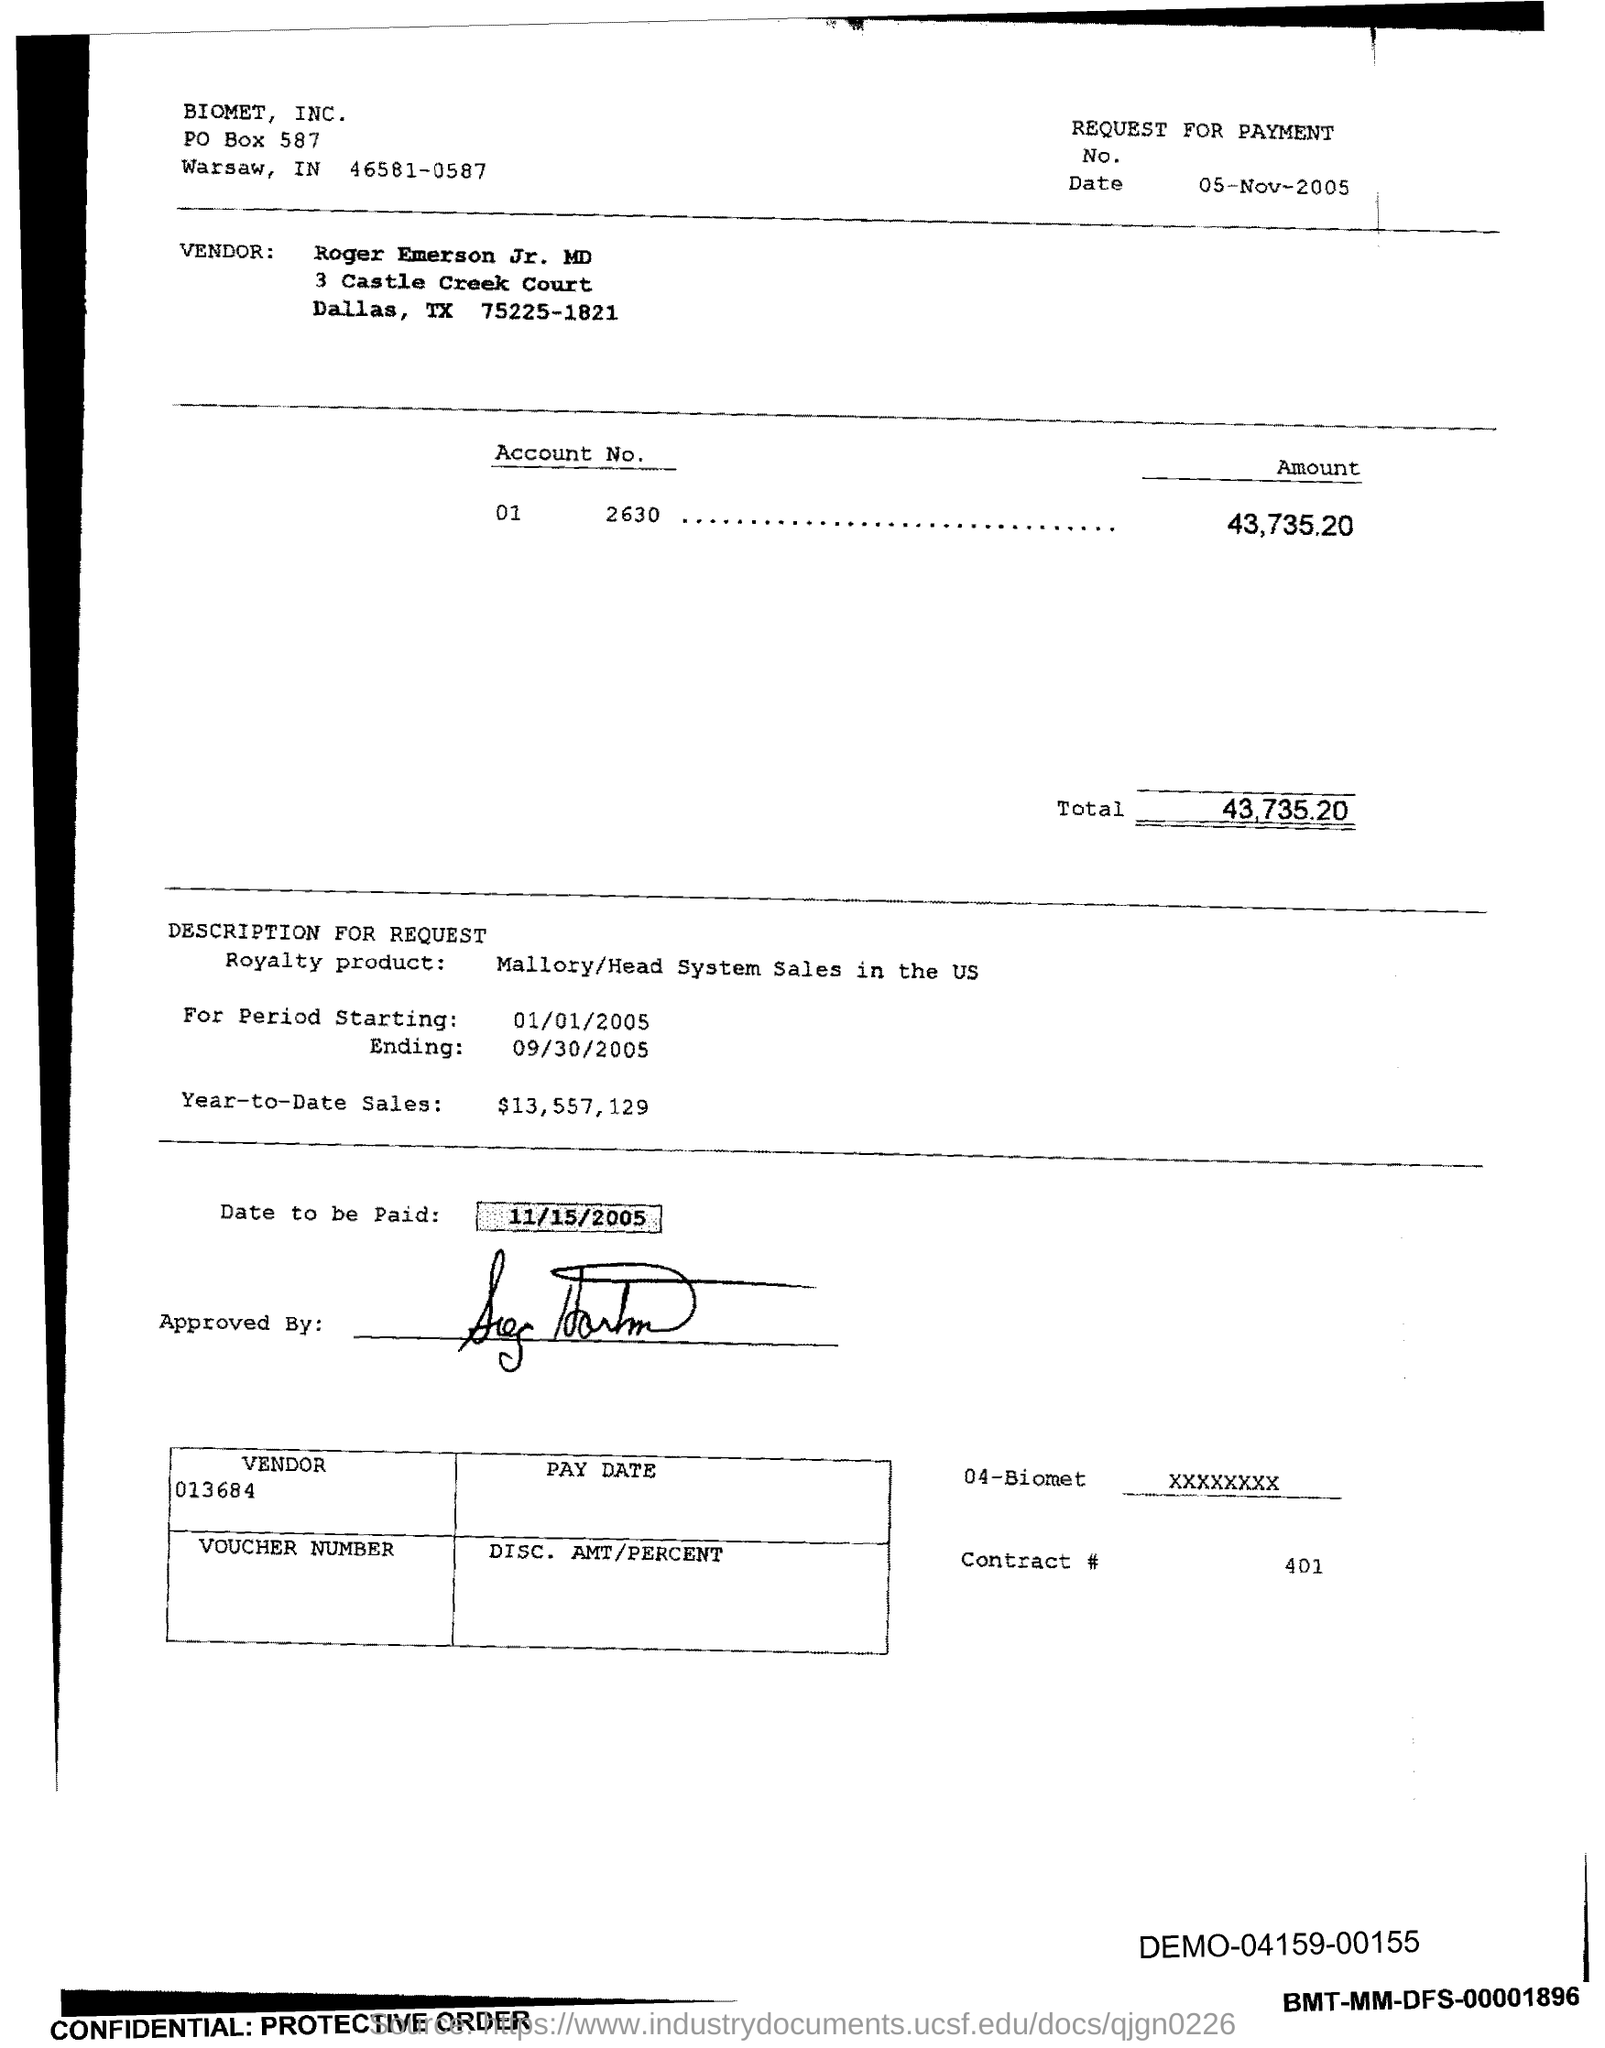Indicate a few pertinent items in this graphic. What is the contract number?" is a question asking for information. The post box number of Biomet is 587. The demo code mentioned in the bottom right corner is DEMO-04159-00155. The starting date is January 1, 2005. What is the date that needs to be paid? It is 11/15/2005. 